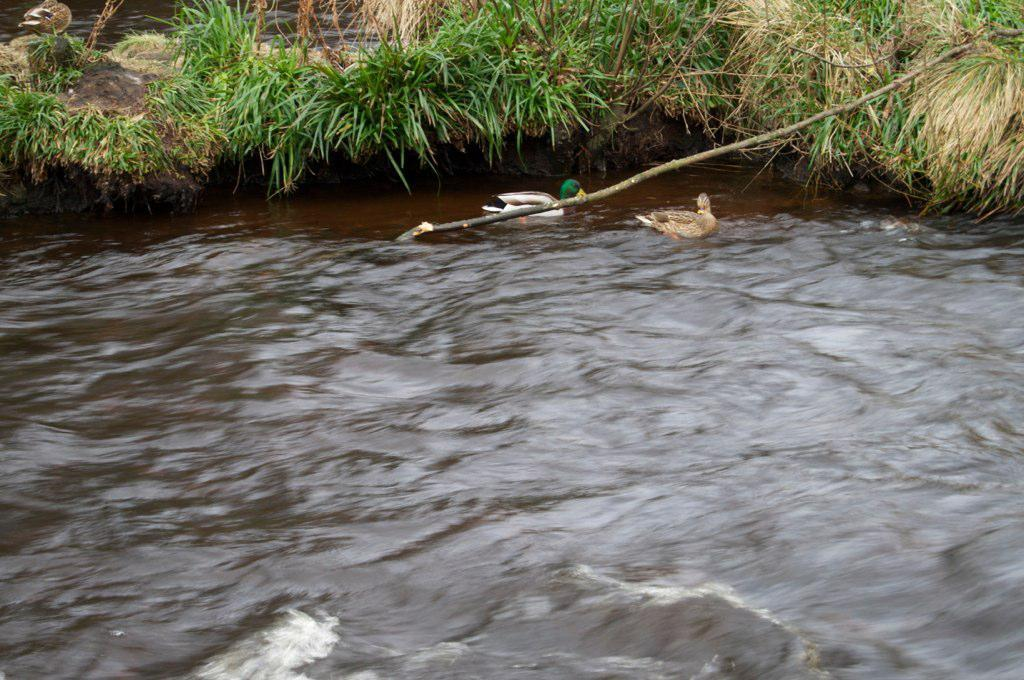What type of animals can be seen in the image? Ducks can be seen in the image. Where are the ducks located? The ducks are in the water. What can be seen in the background of the image? Plants are visible in the background of the image. Who is the owner of the ducks in the image? There is no reference to an owner in the image, so it cannot be determined. 